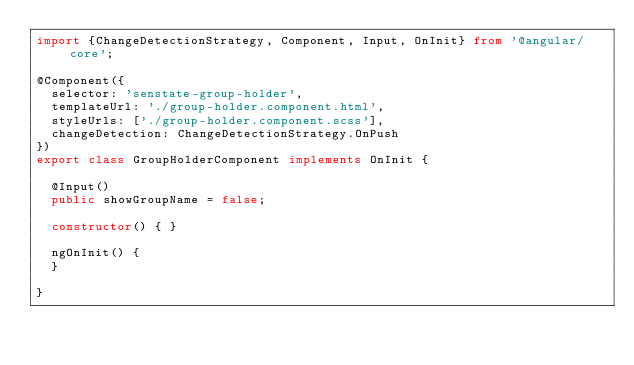Convert code to text. <code><loc_0><loc_0><loc_500><loc_500><_TypeScript_>import {ChangeDetectionStrategy, Component, Input, OnInit} from '@angular/core';

@Component({
  selector: 'senstate-group-holder',
  templateUrl: './group-holder.component.html',
  styleUrls: ['./group-holder.component.scss'],
  changeDetection: ChangeDetectionStrategy.OnPush
})
export class GroupHolderComponent implements OnInit {

  @Input()
  public showGroupName = false;

  constructor() { }

  ngOnInit() {
  }

}
</code> 